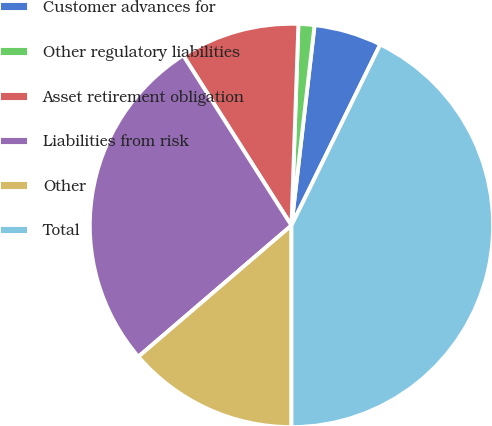Convert chart. <chart><loc_0><loc_0><loc_500><loc_500><pie_chart><fcel>Customer advances for<fcel>Other regulatory liabilities<fcel>Asset retirement obligation<fcel>Liabilities from risk<fcel>Other<fcel>Total<nl><fcel>5.43%<fcel>1.28%<fcel>9.57%<fcel>27.26%<fcel>13.72%<fcel>42.74%<nl></chart> 